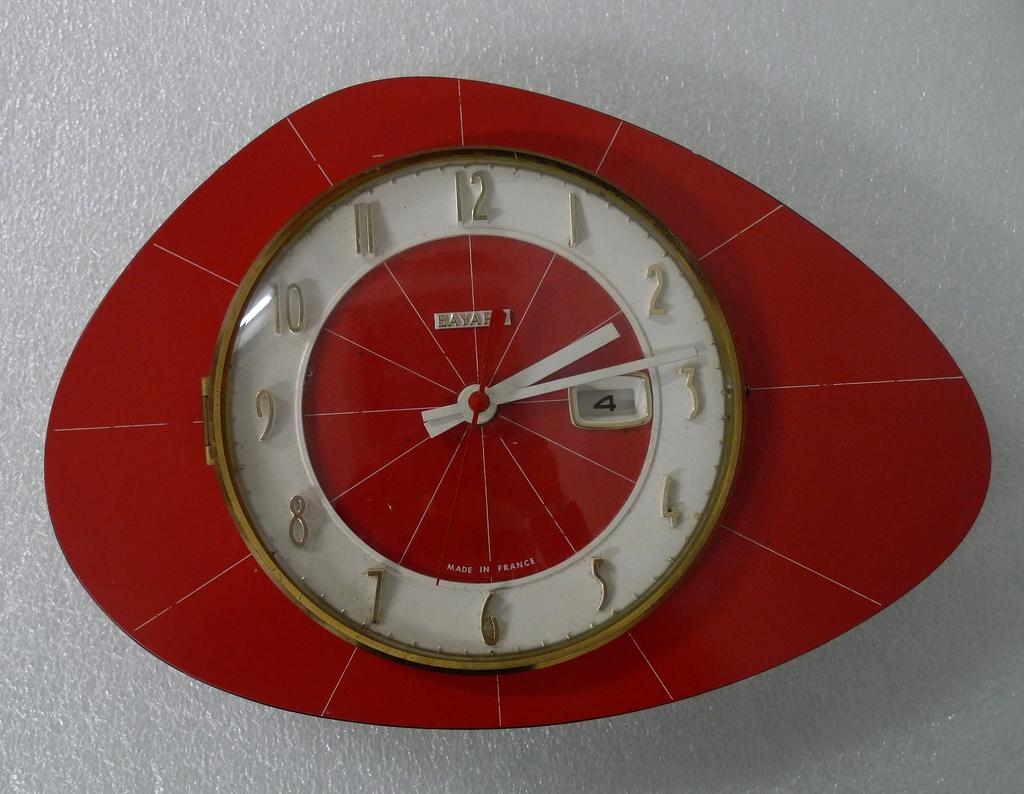Provide a one-sentence caption for the provided image. A interesting shaped clock, that is red and white reads 2:14. 